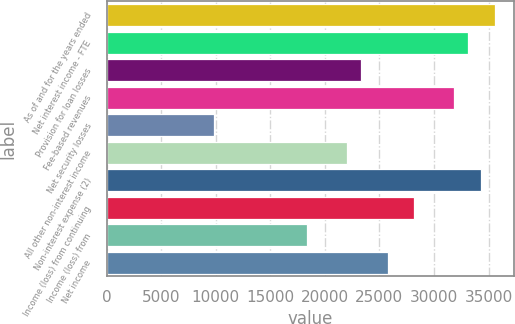<chart> <loc_0><loc_0><loc_500><loc_500><bar_chart><fcel>As of and for the years ended<fcel>Net interest income - FTE<fcel>Provision for loan losses<fcel>Fee-based revenues<fcel>Net security losses<fcel>All other non-interest income<fcel>Non-interest expense (2)<fcel>Income (loss) from continuing<fcel>Income (loss) from<fcel>Net income<nl><fcel>35556.1<fcel>33104<fcel>23295.5<fcel>31878<fcel>9808.88<fcel>22069.5<fcel>34330.1<fcel>28199.8<fcel>18391.3<fcel>25747.7<nl></chart> 